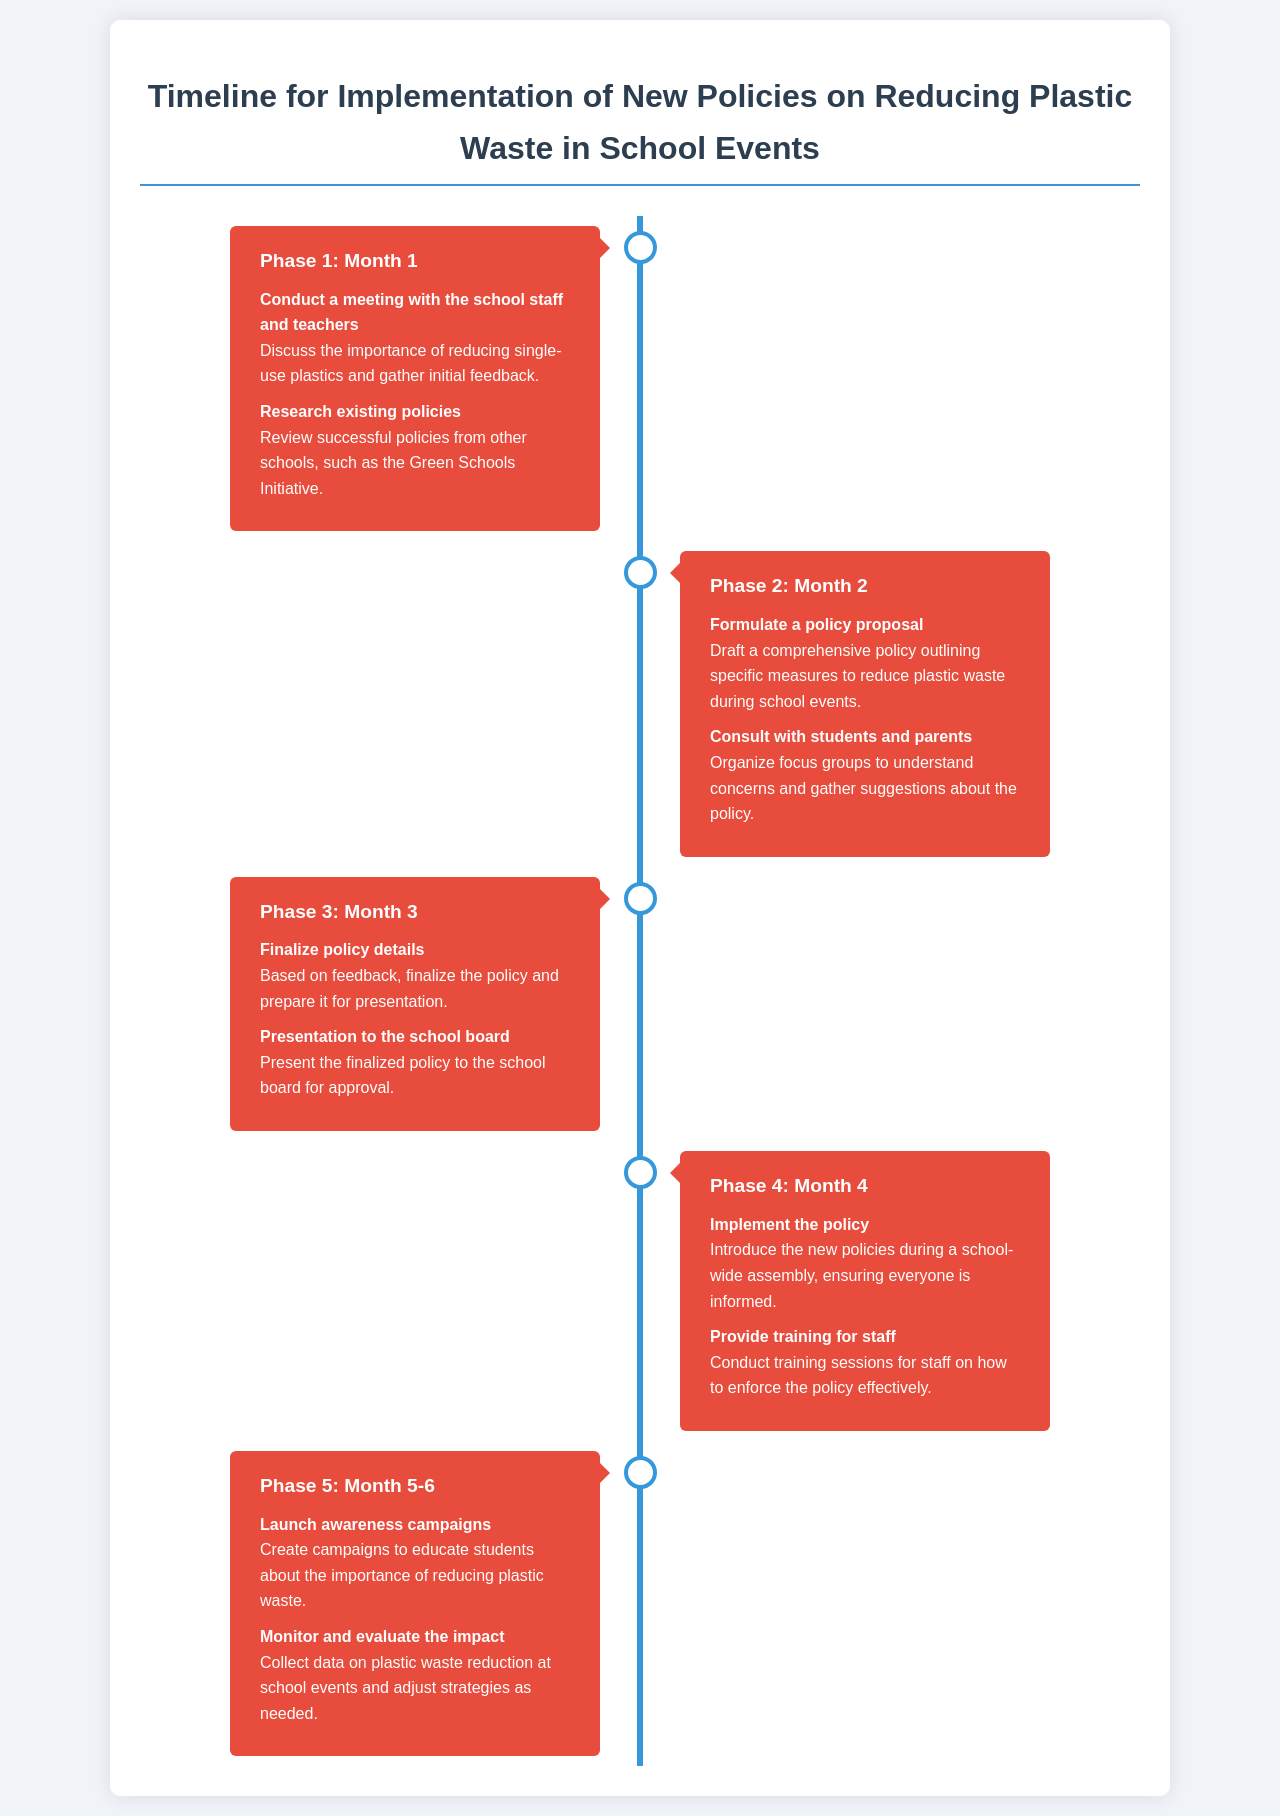what is the title of the document? The title of the document is provided in the header section.
Answer: Timeline for Implementation of New Policies on Reducing Plastic Waste in School Events how many phases are outlined in the document? The document lists a total of five distinct phases for implementation.
Answer: 5 what task is associated with Phase 2? Phase 2 contains specific tasks, including drafting a policy proposal.
Answer: Formulate a policy proposal when will the school board presentation take place? The presentation to the school board is scheduled in Phase 3, specifically in Month 3.
Answer: Month 3 what is the duration of Phase 5? Phase 5 is defined to cover a timeframe of two months.
Answer: Month 5-6 what type of campaign is mentioned in Phase 5? Phase 5 includes launching awareness campaigns as a task.
Answer: awareness campaigns who will be consulted for feedback in Phase 2? Phase 2 involves consulting specific groups to gather insights on the proposed policy.
Answer: students and parents what is the first task in Phase 1? The first task in Phase 1 is to conduct a meeting with school staff and teachers.
Answer: Conduct a meeting with the school staff and teachers what color represents the primary theme of the timeline? The primary color used throughout the timeline indicating branding is blue.
Answer: blue 